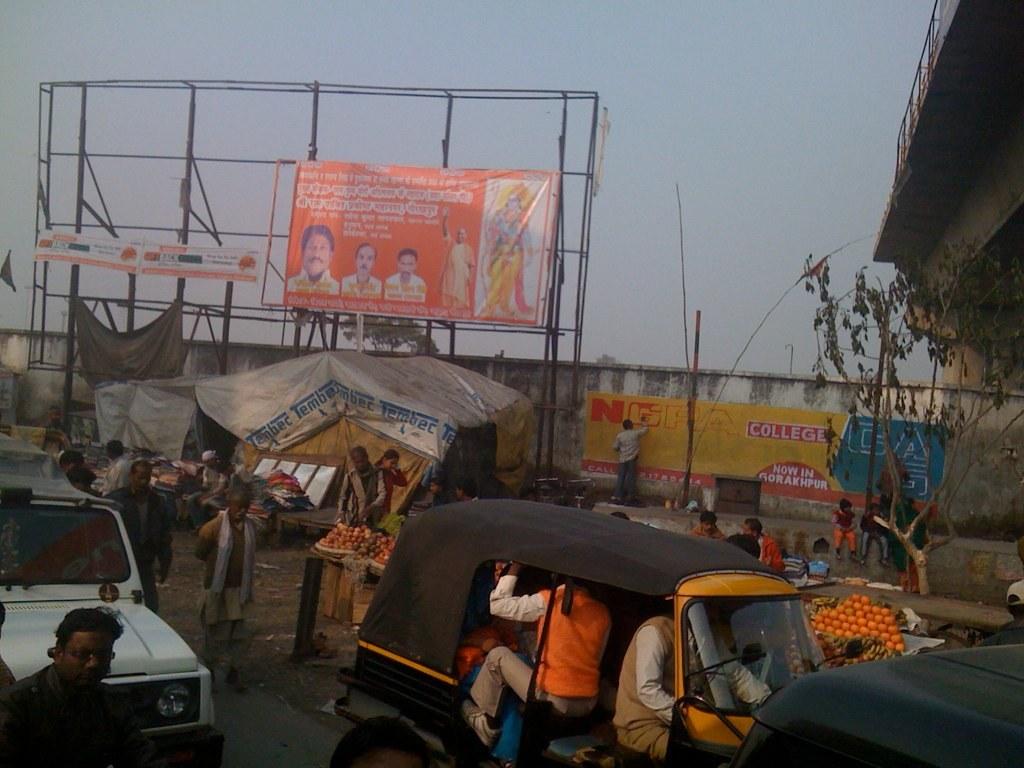What letter is the man painting onto the yellow sign?
Offer a terse response. G. 